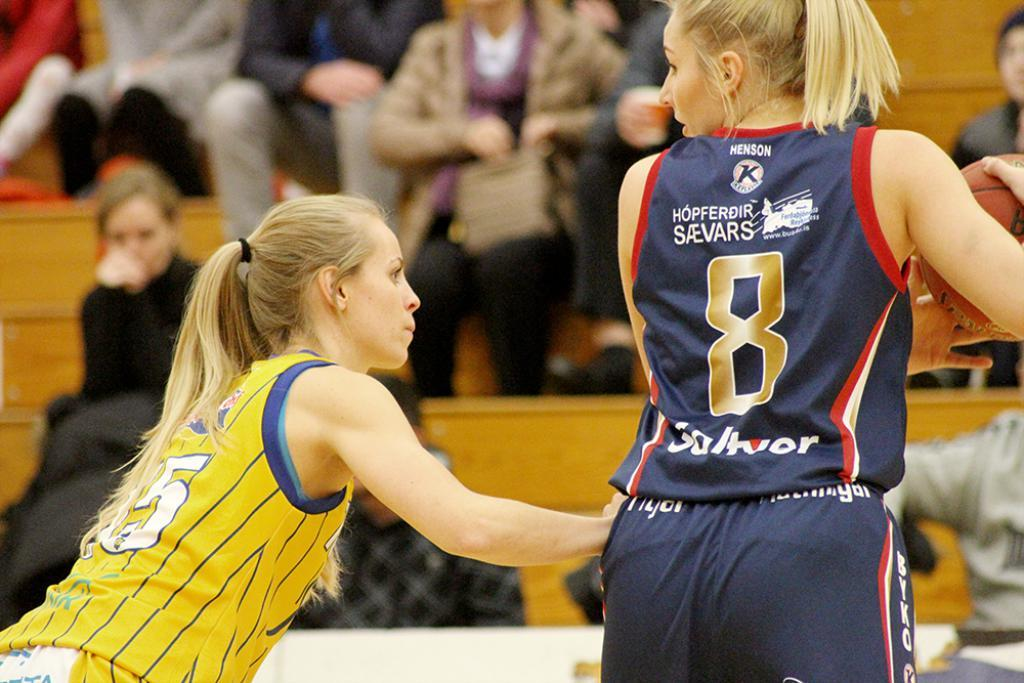<image>
Provide a brief description of the given image. Two female basketball players, one with the ball and a golden number 8 on the back of her jersey. 